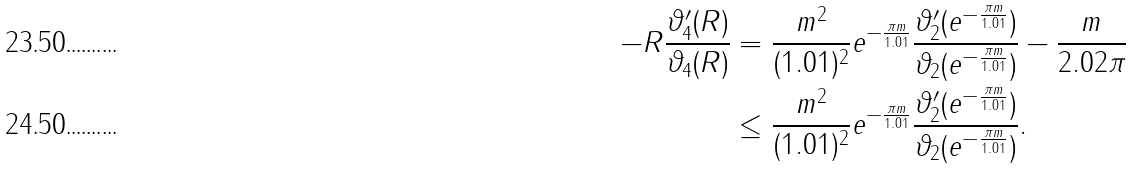<formula> <loc_0><loc_0><loc_500><loc_500>- R \frac { \vartheta _ { 4 } ^ { \prime } ( R ) } { \vartheta _ { 4 } ( R ) } & = \frac { m ^ { 2 } } { ( 1 . 0 1 ) ^ { 2 } } e ^ { - \frac { \pi m } { 1 . 0 1 } } \frac { \vartheta ^ { \prime } _ { 2 } ( e ^ { - \frac { \pi m } { 1 . 0 1 } } ) } { \vartheta _ { 2 } ( e ^ { - \frac { \pi m } { 1 . 0 1 } } ) } - \frac { m } { 2 . 0 2 \pi } \\ & \leq \frac { m ^ { 2 } } { ( 1 . 0 1 ) ^ { 2 } } e ^ { - \frac { \pi m } { 1 . 0 1 } } \frac { \vartheta ^ { \prime } _ { 2 } ( e ^ { - \frac { \pi m } { 1 . 0 1 } } ) } { \vartheta _ { 2 } ( e ^ { - \frac { \pi m } { 1 . 0 1 } } ) } .</formula> 